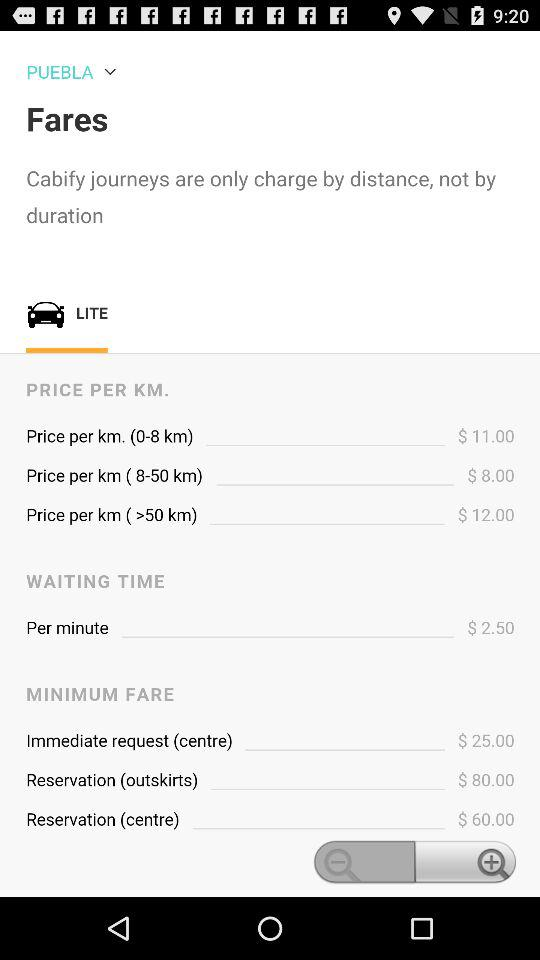How much is the price per km for a distance of 8-50 km?
Answer the question using a single word or phrase. $8.00 